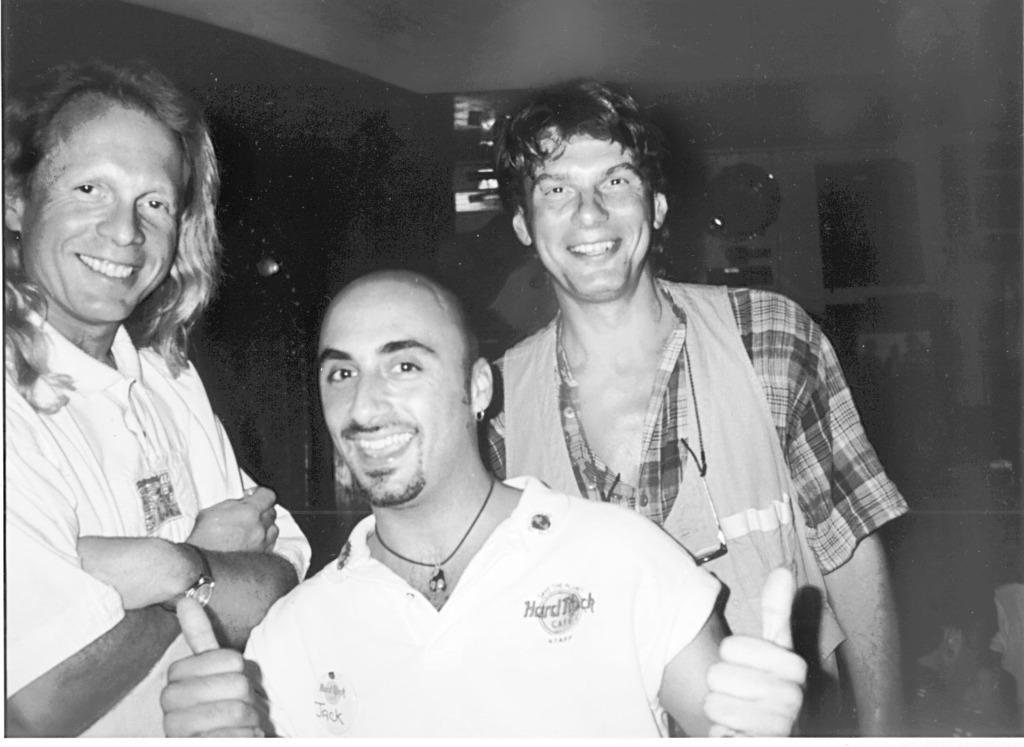Can you describe this image briefly? In the picture we can see three men are standing and smiling, one man is in long hair and one man is in bald head and in the background, we can see the wall with something are placed on it in the dark. 